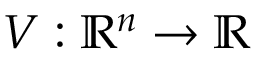<formula> <loc_0><loc_0><loc_500><loc_500>V \colon { \mathbb { R } } ^ { n } \rightarrow { \mathbb { R } }</formula> 